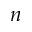<formula> <loc_0><loc_0><loc_500><loc_500>n</formula> 